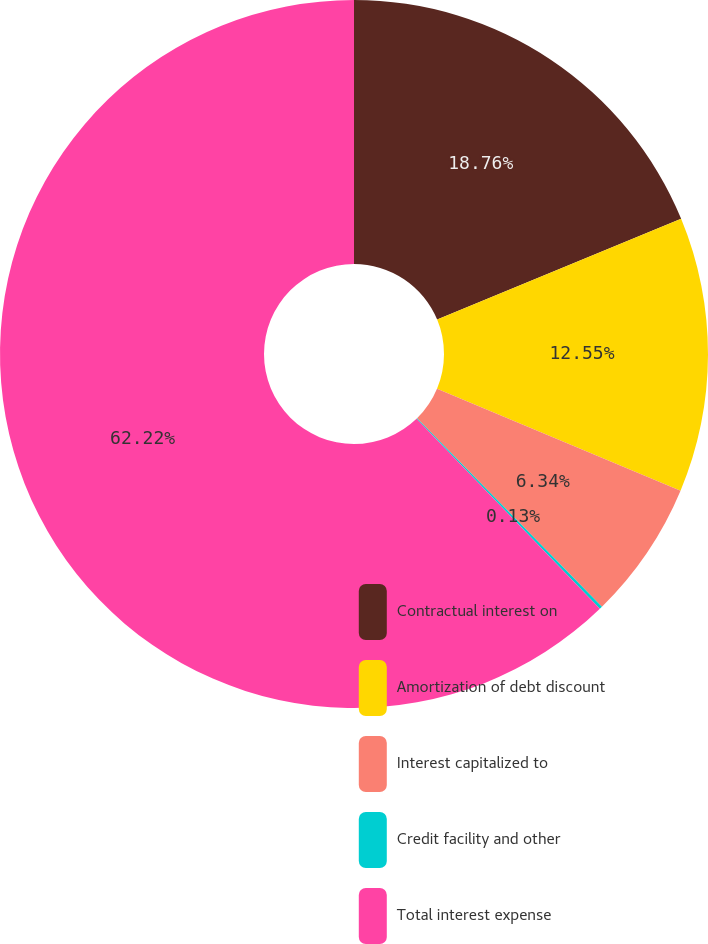Convert chart to OTSL. <chart><loc_0><loc_0><loc_500><loc_500><pie_chart><fcel>Contractual interest on<fcel>Amortization of debt discount<fcel>Interest capitalized to<fcel>Credit facility and other<fcel>Total interest expense<nl><fcel>18.76%<fcel>12.55%<fcel>6.34%<fcel>0.13%<fcel>62.22%<nl></chart> 